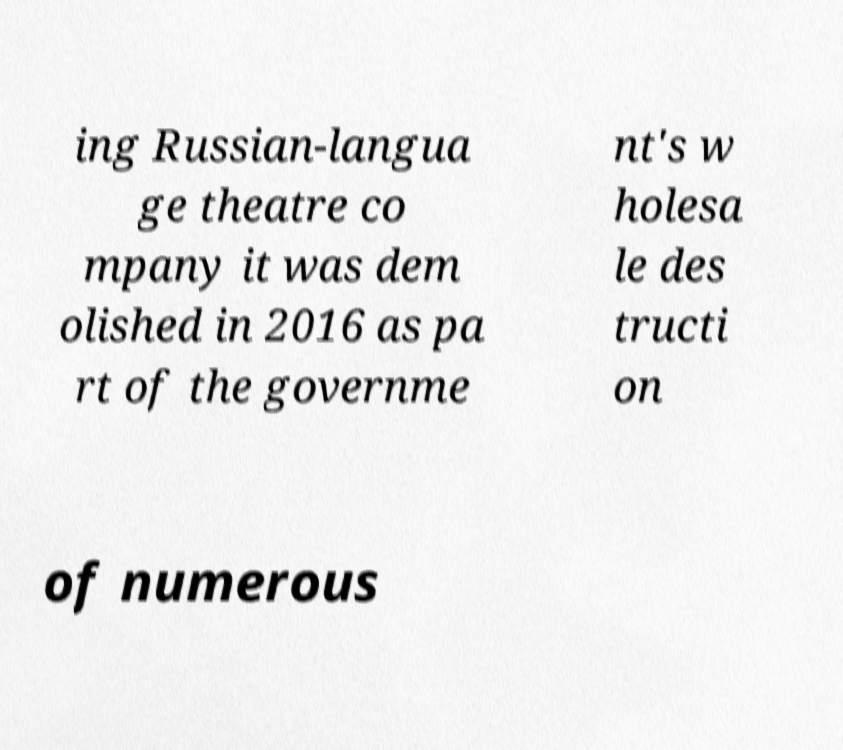Could you extract and type out the text from this image? ing Russian-langua ge theatre co mpany it was dem olished in 2016 as pa rt of the governme nt's w holesa le des tructi on of numerous 